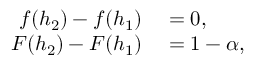Convert formula to latex. <formula><loc_0><loc_0><loc_500><loc_500>\begin{array} { r l } { f ( h _ { 2 } ) - f ( h _ { 1 } ) } & = 0 , } \\ { F ( h _ { 2 } ) - F ( h _ { 1 } ) } & = 1 - \alpha , } \end{array}</formula> 